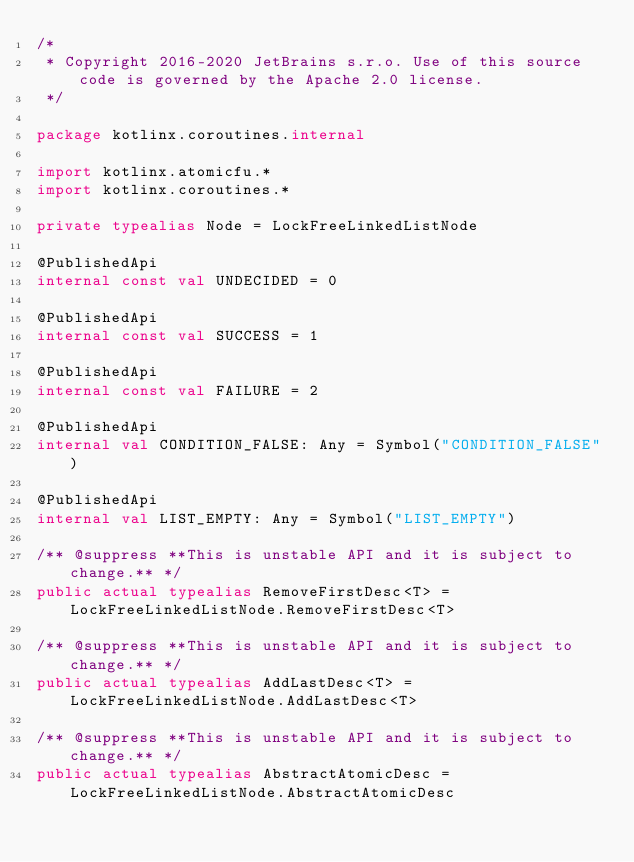Convert code to text. <code><loc_0><loc_0><loc_500><loc_500><_Kotlin_>/*
 * Copyright 2016-2020 JetBrains s.r.o. Use of this source code is governed by the Apache 2.0 license.
 */

package kotlinx.coroutines.internal

import kotlinx.atomicfu.*
import kotlinx.coroutines.*

private typealias Node = LockFreeLinkedListNode

@PublishedApi
internal const val UNDECIDED = 0

@PublishedApi
internal const val SUCCESS = 1

@PublishedApi
internal const val FAILURE = 2

@PublishedApi
internal val CONDITION_FALSE: Any = Symbol("CONDITION_FALSE")

@PublishedApi
internal val LIST_EMPTY: Any = Symbol("LIST_EMPTY")

/** @suppress **This is unstable API and it is subject to change.** */
public actual typealias RemoveFirstDesc<T> = LockFreeLinkedListNode.RemoveFirstDesc<T>

/** @suppress **This is unstable API and it is subject to change.** */
public actual typealias AddLastDesc<T> = LockFreeLinkedListNode.AddLastDesc<T>

/** @suppress **This is unstable API and it is subject to change.** */
public actual typealias AbstractAtomicDesc = LockFreeLinkedListNode.AbstractAtomicDesc
</code> 